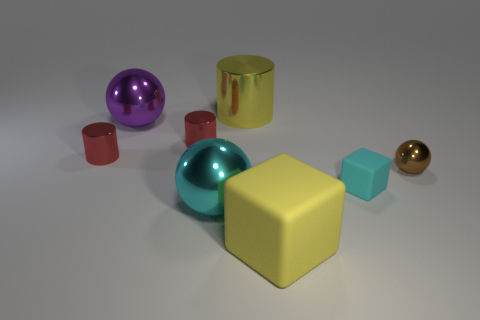There is a purple thing that is the same shape as the large cyan metal thing; what size is it?
Your answer should be compact. Large. Is there a small cyan thing?
Offer a terse response. Yes. There is a big shiny cylinder; is its color the same as the rubber block in front of the cyan shiny thing?
Offer a terse response. Yes. There is a block that is to the right of the rubber object that is in front of the metal ball in front of the small sphere; how big is it?
Provide a short and direct response. Small. How many large shiny spheres are the same color as the big shiny cylinder?
Make the answer very short. 0. How many things are either red shiny objects or matte objects behind the big yellow cube?
Give a very brief answer. 3. What is the color of the large rubber block?
Offer a very short reply. Yellow. There is a metal ball on the right side of the large yellow cylinder; what color is it?
Provide a short and direct response. Brown. There is a block that is behind the yellow rubber block; what number of small shiny balls are left of it?
Give a very brief answer. 0. There is a yellow rubber cube; is it the same size as the purple sphere behind the big yellow rubber object?
Ensure brevity in your answer.  Yes. 